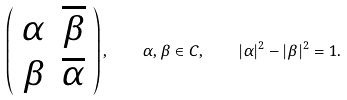Convert formula to latex. <formula><loc_0><loc_0><loc_500><loc_500>\left ( \begin{array} { c c } \alpha & \overline { \beta } \\ \beta & \overline { \alpha } \end{array} \right ) , \quad \alpha , \beta \in C , \quad | \alpha | ^ { 2 } - | \beta | ^ { 2 } = 1 .</formula> 